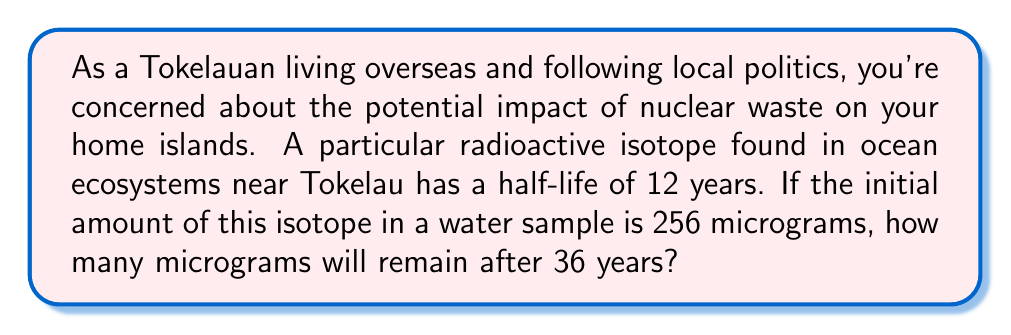Solve this math problem. Let's approach this step-by-step using the exponential decay formula:

1) The exponential decay formula is:

   $$A(t) = A_0 \cdot (\frac{1}{2})^{\frac{t}{t_{1/2}}}$$

   Where:
   $A(t)$ is the amount remaining after time $t$
   $A_0$ is the initial amount
   $t$ is the time elapsed
   $t_{1/2}$ is the half-life

2) We know:
   $A_0 = 256$ micrograms
   $t = 36$ years
   $t_{1/2} = 12$ years

3) Let's substitute these values into the formula:

   $$A(36) = 256 \cdot (\frac{1}{2})^{\frac{36}{12}}$$

4) Simplify the exponent:

   $$A(36) = 256 \cdot (\frac{1}{2})^3$$

5) Calculate $(\frac{1}{2})^3$:

   $$(\frac{1}{2})^3 = \frac{1}{8}$$

6) Now our equation looks like:

   $$A(36) = 256 \cdot \frac{1}{8}$$

7) Solve:

   $$A(36) = 32$$

Therefore, after 36 years, 32 micrograms of the radioactive isotope will remain.
Answer: 32 micrograms 